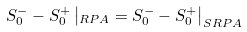<formula> <loc_0><loc_0><loc_500><loc_500>S ^ { - } _ { 0 } - S ^ { + } _ { 0 } \left | _ { R P A } = S ^ { - } _ { 0 } - S ^ { + } _ { 0 } \right | _ { S R P A }</formula> 